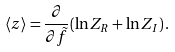Convert formula to latex. <formula><loc_0><loc_0><loc_500><loc_500>\langle z \rangle = \frac { \partial } { \partial \tilde { f } } ( \ln Z _ { R } + \ln Z _ { I } ) \, .</formula> 